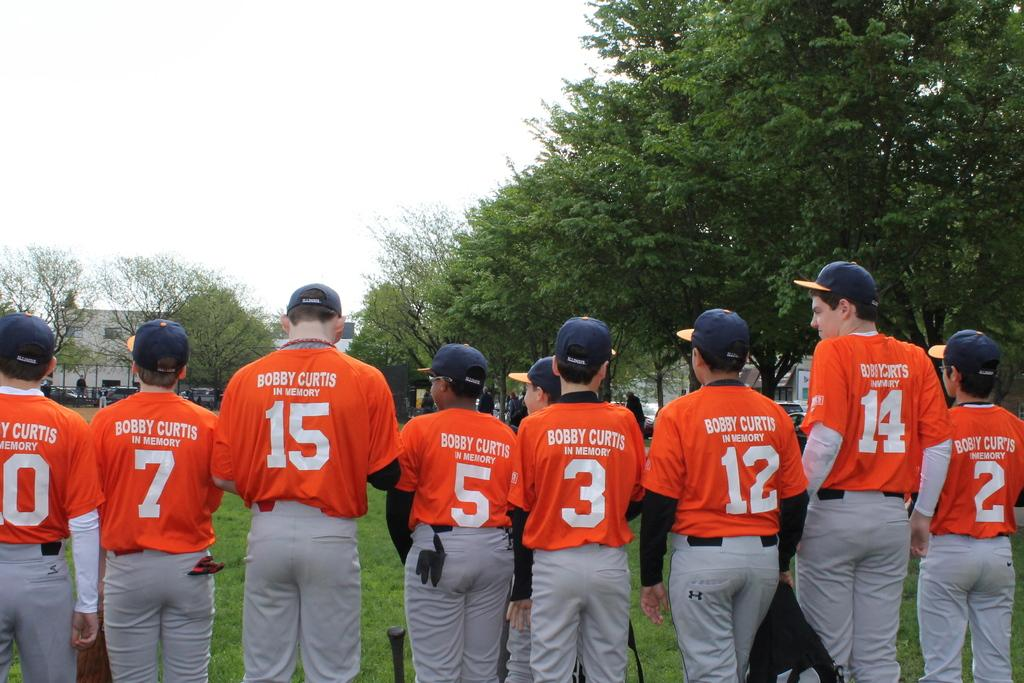<image>
Offer a succinct explanation of the picture presented. The baseball players are standing next to each other with BOBBY CURTIS IN MEMORY on the back of their shirts. 